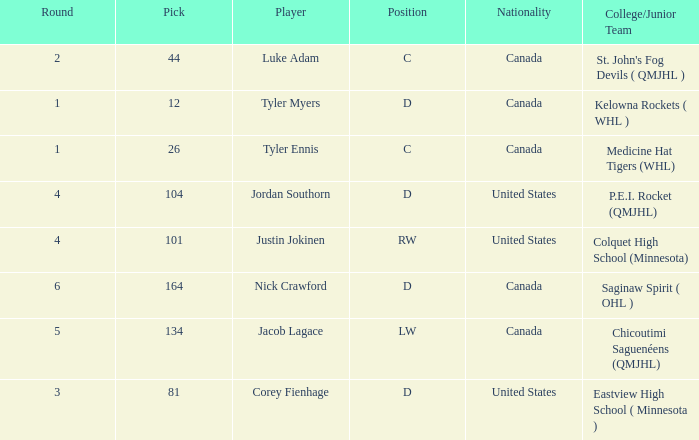What is the average round of the rw position player from the United States? 4.0. 